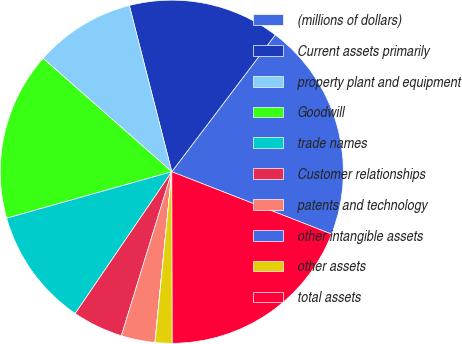Convert chart. <chart><loc_0><loc_0><loc_500><loc_500><pie_chart><fcel>(millions of dollars)<fcel>Current assets primarily<fcel>property plant and equipment<fcel>Goodwill<fcel>trade names<fcel>Customer relationships<fcel>patents and technology<fcel>other intangible assets<fcel>other assets<fcel>total assets<nl><fcel>20.62%<fcel>14.28%<fcel>9.52%<fcel>15.86%<fcel>11.11%<fcel>4.77%<fcel>3.18%<fcel>0.01%<fcel>1.6%<fcel>19.03%<nl></chart> 